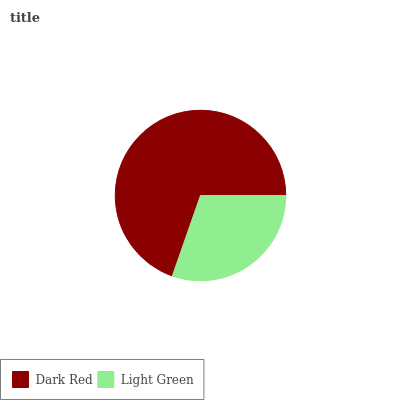Is Light Green the minimum?
Answer yes or no. Yes. Is Dark Red the maximum?
Answer yes or no. Yes. Is Light Green the maximum?
Answer yes or no. No. Is Dark Red greater than Light Green?
Answer yes or no. Yes. Is Light Green less than Dark Red?
Answer yes or no. Yes. Is Light Green greater than Dark Red?
Answer yes or no. No. Is Dark Red less than Light Green?
Answer yes or no. No. Is Dark Red the high median?
Answer yes or no. Yes. Is Light Green the low median?
Answer yes or no. Yes. Is Light Green the high median?
Answer yes or no. No. Is Dark Red the low median?
Answer yes or no. No. 